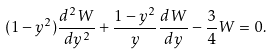<formula> <loc_0><loc_0><loc_500><loc_500>( 1 - y ^ { 2 } ) \frac { d ^ { 2 } W } { d y ^ { 2 } } + \frac { 1 - y ^ { 2 } } { y } \frac { d W } { d y } - \frac { 3 } { 4 } W = 0 .</formula> 